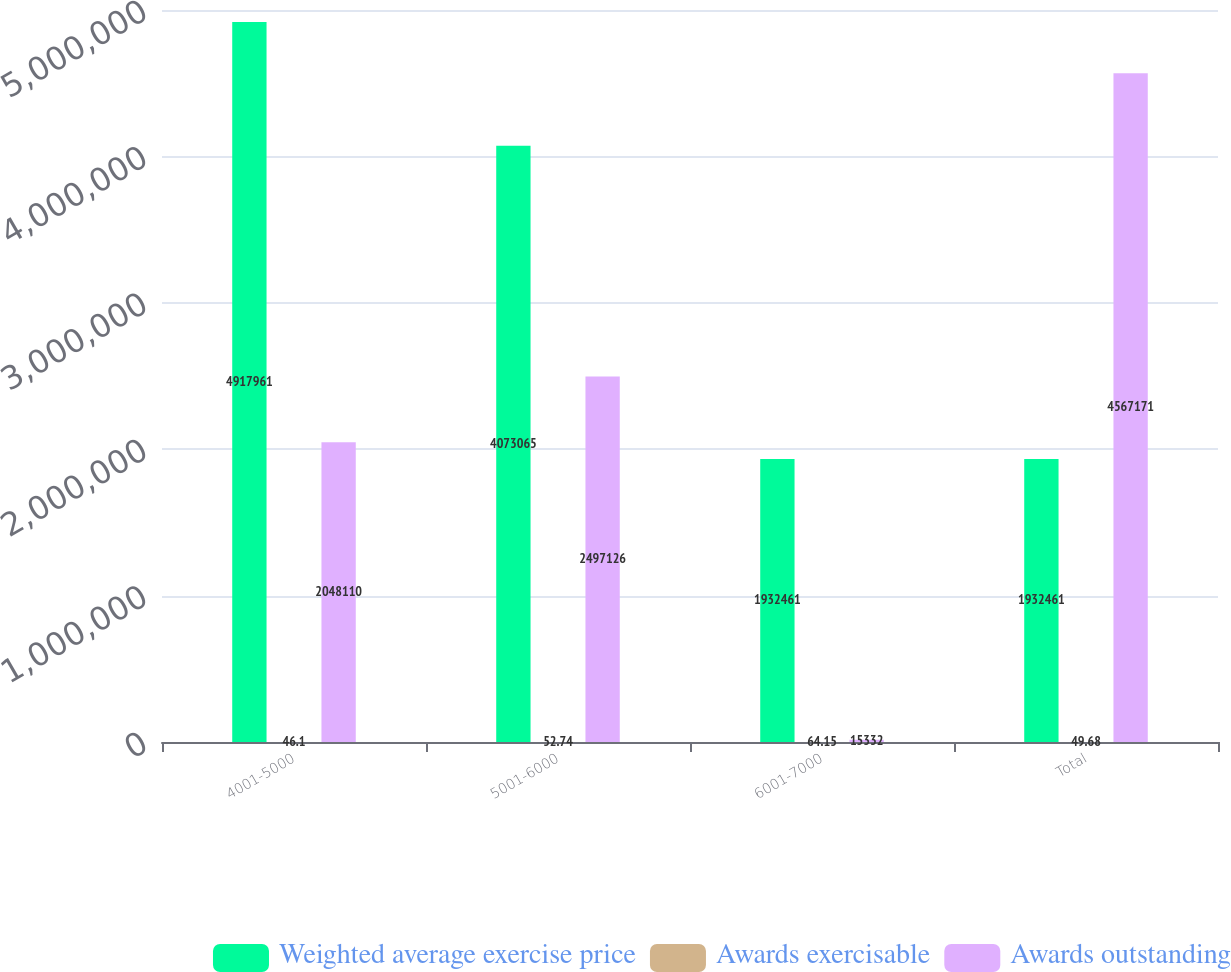Convert chart to OTSL. <chart><loc_0><loc_0><loc_500><loc_500><stacked_bar_chart><ecel><fcel>4001-5000<fcel>5001-6000<fcel>6001-7000<fcel>Total<nl><fcel>Weighted average exercise price<fcel>4.91796e+06<fcel>4.07306e+06<fcel>1.93246e+06<fcel>1.93246e+06<nl><fcel>Awards exercisable<fcel>46.1<fcel>52.74<fcel>64.15<fcel>49.68<nl><fcel>Awards outstanding<fcel>2.04811e+06<fcel>2.49713e+06<fcel>15332<fcel>4.56717e+06<nl></chart> 